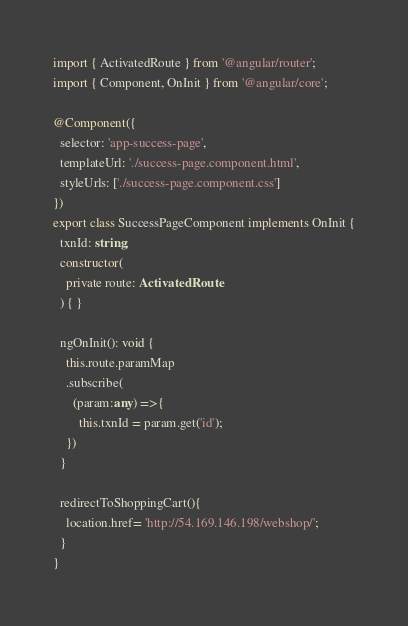<code> <loc_0><loc_0><loc_500><loc_500><_TypeScript_>import { ActivatedRoute } from '@angular/router';
import { Component, OnInit } from '@angular/core';

@Component({
  selector: 'app-success-page',
  templateUrl: './success-page.component.html',
  styleUrls: ['./success-page.component.css']
})
export class SuccessPageComponent implements OnInit {
  txnId: string;
  constructor(
    private route: ActivatedRoute
  ) { }

  ngOnInit(): void {
    this.route.paramMap
    .subscribe(
      (param:any) =>{
        this.txnId = param.get('id');
    })
  }

  redirectToShoppingCart(){
    location.href= 'http://54.169.146.198/webshop/'; 
  }
}
</code> 